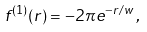<formula> <loc_0><loc_0><loc_500><loc_500>f ^ { ( 1 ) } ( r ) = - 2 \pi e ^ { - r / w } \, ,</formula> 